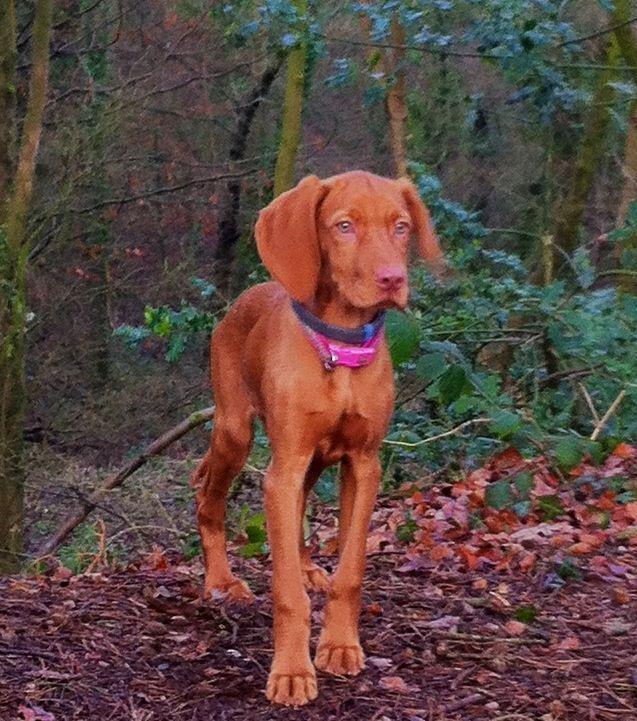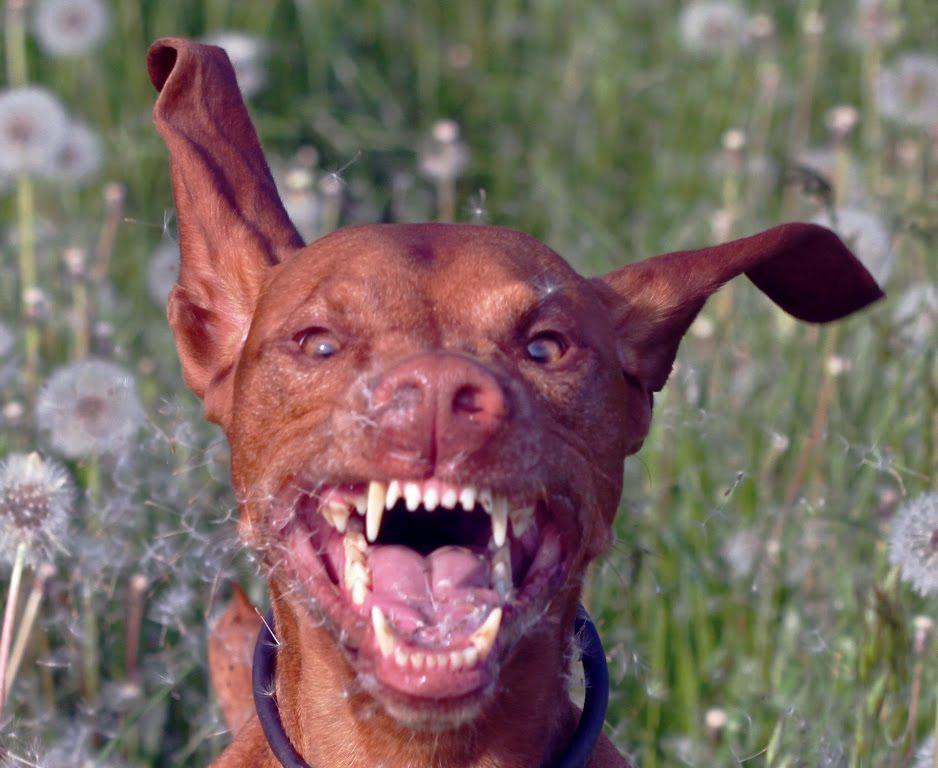The first image is the image on the left, the second image is the image on the right. Given the left and right images, does the statement "The dog in the image on the left is standing up outside." hold true? Answer yes or no. Yes. The first image is the image on the left, the second image is the image on the right. For the images displayed, is the sentence "In one image, a dog's upright head and shoulders are behind a squarish flat surface which its front paws are over." factually correct? Answer yes or no. No. 